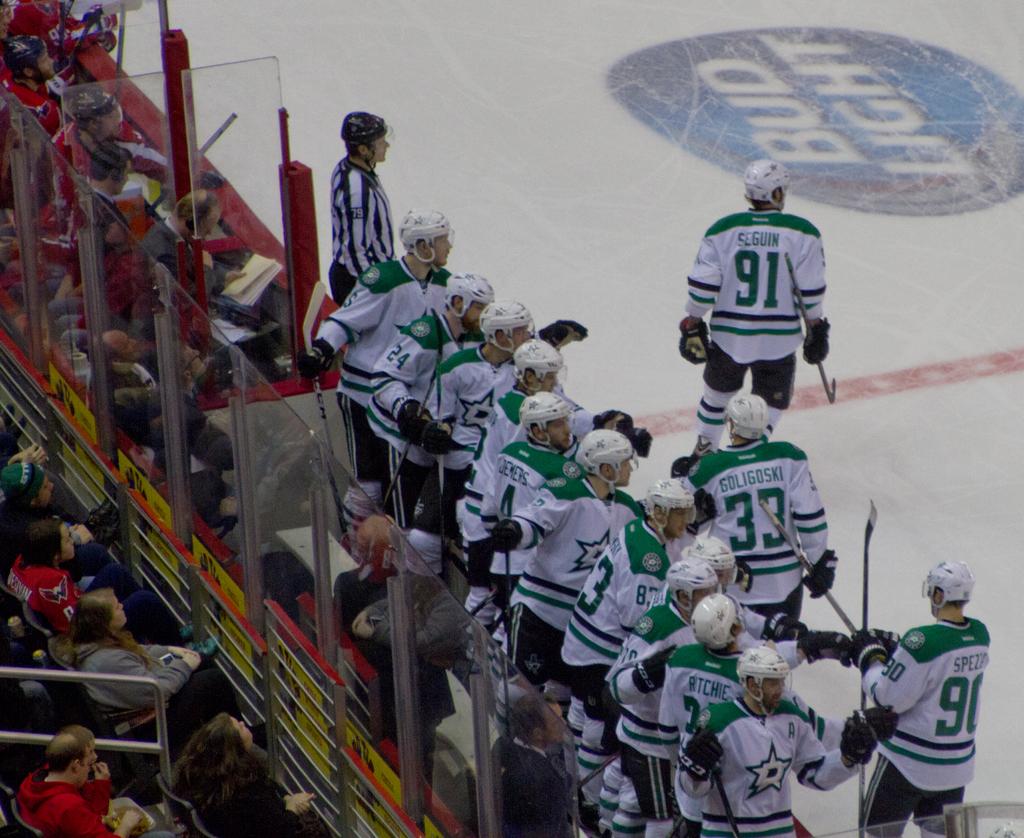What beer brand is advertised on the ice?
Offer a very short reply. Bud light. 